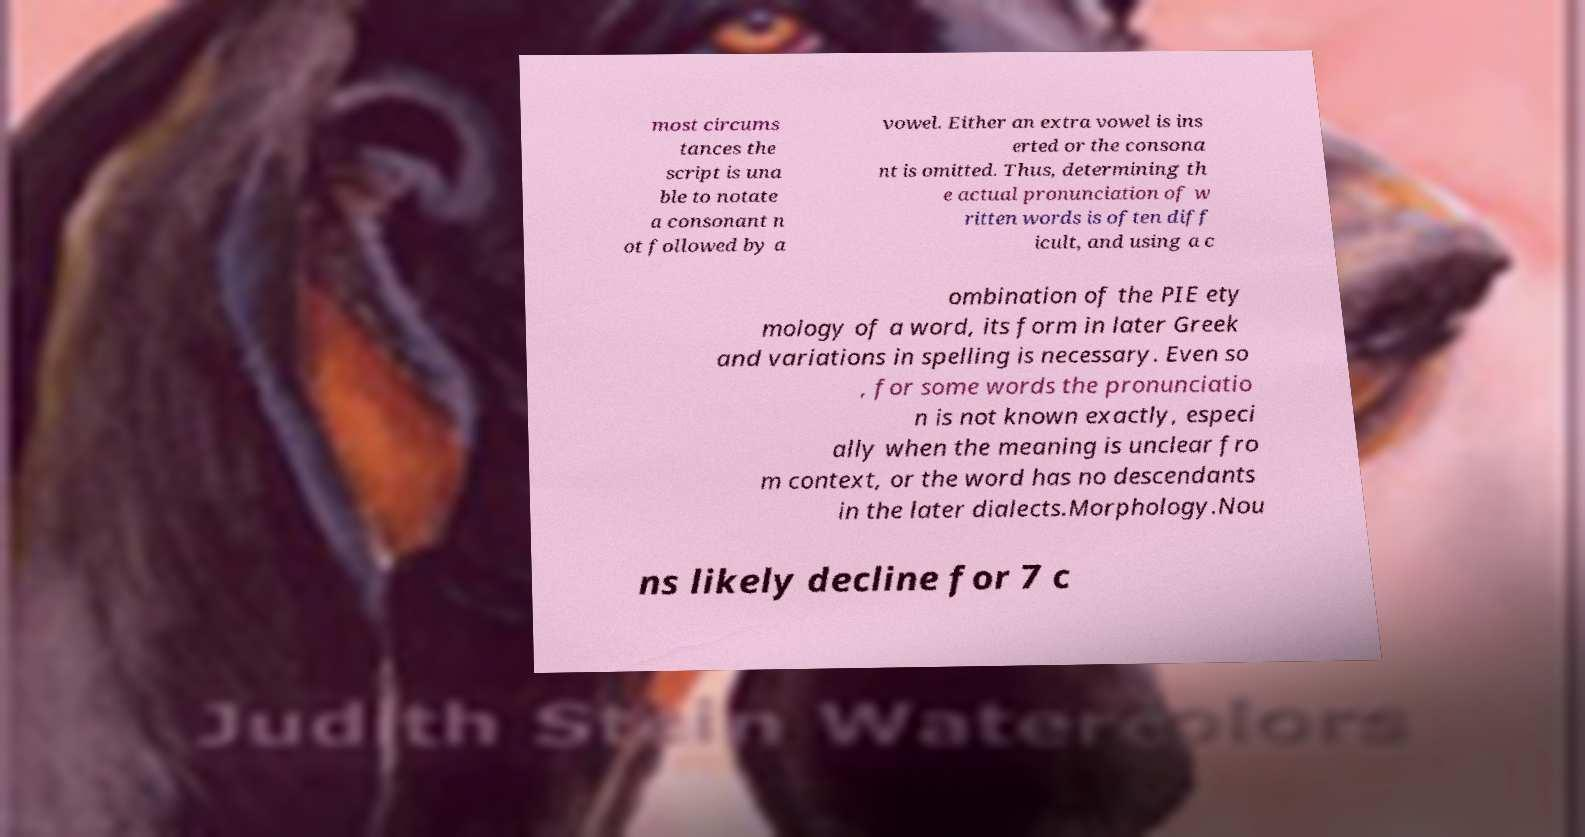Can you accurately transcribe the text from the provided image for me? most circums tances the script is una ble to notate a consonant n ot followed by a vowel. Either an extra vowel is ins erted or the consona nt is omitted. Thus, determining th e actual pronunciation of w ritten words is often diff icult, and using a c ombination of the PIE ety mology of a word, its form in later Greek and variations in spelling is necessary. Even so , for some words the pronunciatio n is not known exactly, especi ally when the meaning is unclear fro m context, or the word has no descendants in the later dialects.Morphology.Nou ns likely decline for 7 c 